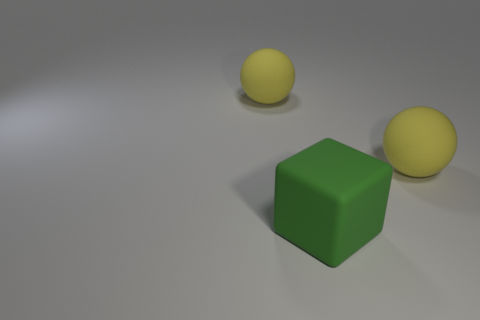What's the approximate relative size of the green cube compared to the yellow balls? The green cube appears to be about the same height as the diameter of the yellow balls, suggesting they are of comparable size. 